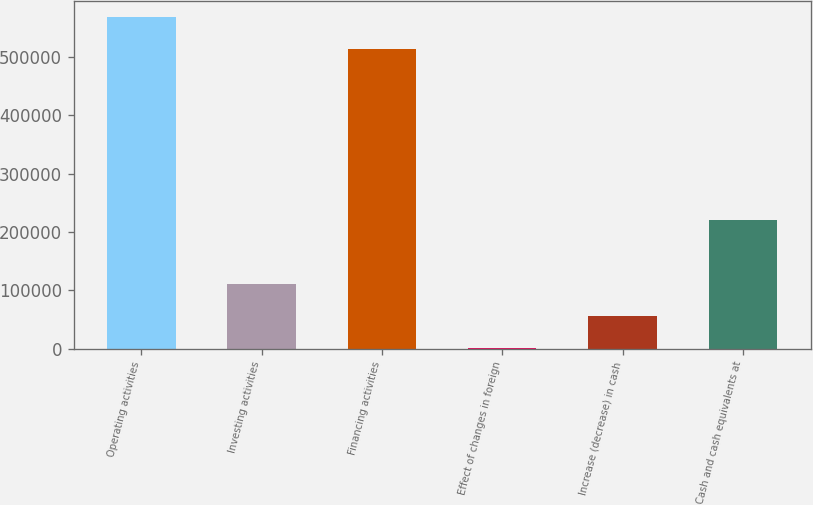<chart> <loc_0><loc_0><loc_500><loc_500><bar_chart><fcel>Operating activities<fcel>Investing activities<fcel>Financing activities<fcel>Effect of changes in foreign<fcel>Increase (decrease) in cash<fcel>Cash and cash equivalents at<nl><fcel>567911<fcel>110191<fcel>513072<fcel>513<fcel>55351.9<fcel>219869<nl></chart> 